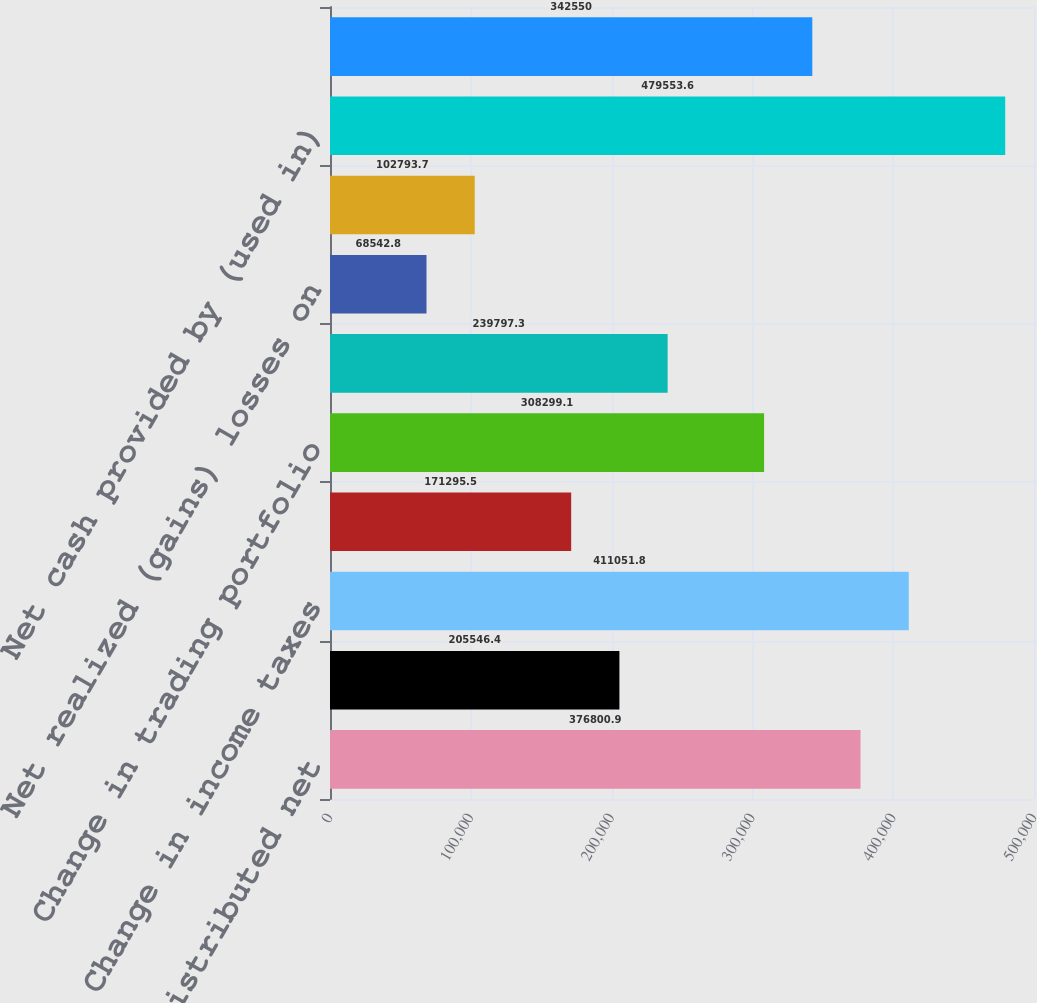<chart> <loc_0><loc_0><loc_500><loc_500><bar_chart><fcel>Equity in undistributed net<fcel>Change in receivables<fcel>Change in income taxes<fcel>Change in accounts payable and<fcel>Change in trading portfolio<fcel>Depreciationandamortization<fcel>Net realized (gains) losses on<fcel>Other<fcel>Net cash provided by (used in)<fcel>Property and equipment<nl><fcel>376801<fcel>205546<fcel>411052<fcel>171296<fcel>308299<fcel>239797<fcel>68542.8<fcel>102794<fcel>479554<fcel>342550<nl></chart> 